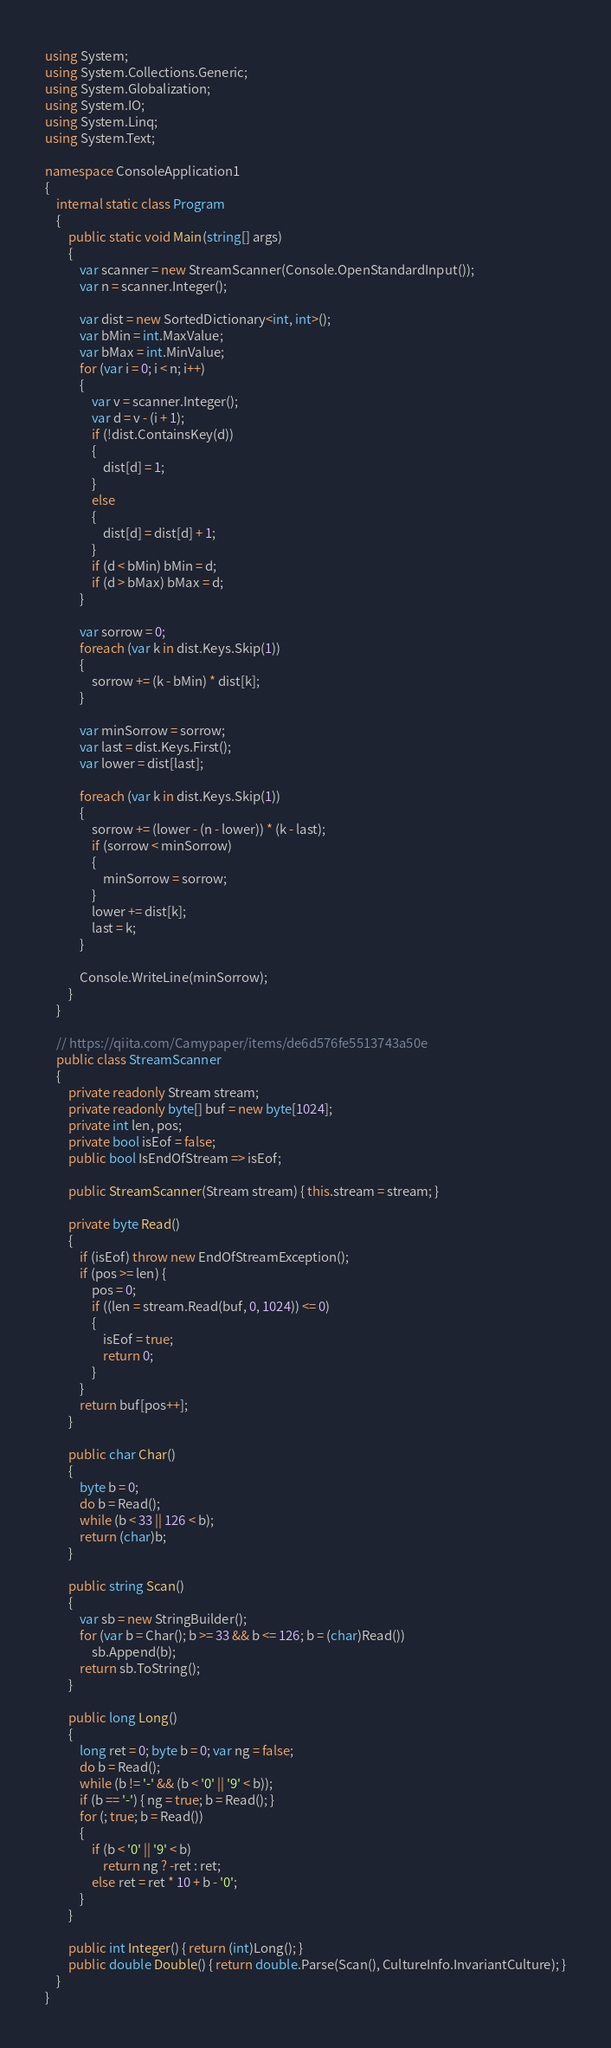<code> <loc_0><loc_0><loc_500><loc_500><_C#_>using System;
using System.Collections.Generic;
using System.Globalization;
using System.IO;
using System.Linq;
using System.Text;

namespace ConsoleApplication1
{
    internal static class Program
    {
        public static void Main(string[] args)
        {
            var scanner = new StreamScanner(Console.OpenStandardInput());
            var n = scanner.Integer();

            var dist = new SortedDictionary<int, int>();
            var bMin = int.MaxValue;
            var bMax = int.MinValue;
            for (var i = 0; i < n; i++)
            {
                var v = scanner.Integer();
                var d = v - (i + 1);
                if (!dist.ContainsKey(d))
                {
                    dist[d] = 1;
                }
                else
                {
                    dist[d] = dist[d] + 1;
                }
                if (d < bMin) bMin = d;
                if (d > bMax) bMax = d;
            }

            var sorrow = 0;
            foreach (var k in dist.Keys.Skip(1))
            {
                sorrow += (k - bMin) * dist[k];
            }
            
            var minSorrow = sorrow;
            var last = dist.Keys.First();
            var lower = dist[last];

            foreach (var k in dist.Keys.Skip(1))
            {
                sorrow += (lower - (n - lower)) * (k - last);
                if (sorrow < minSorrow)
                {
                    minSorrow = sorrow;
                }
                lower += dist[k];
                last = k;
            }
            
            Console.WriteLine(minSorrow);
        }
    }
    
    // https://qiita.com/Camypaper/items/de6d576fe5513743a50e
    public class StreamScanner
    {   
        private readonly Stream stream;
        private readonly byte[] buf = new byte[1024];
        private int len, pos;
        private bool isEof = false;
        public bool IsEndOfStream => isEof;

        public StreamScanner(Stream stream) { this.stream = stream; }
        
        private byte Read()
        {
            if (isEof) throw new EndOfStreamException();
            if (pos >= len) {
                pos = 0;
                if ((len = stream.Read(buf, 0, 1024)) <= 0)
                {
                    isEof = true;
                    return 0;
                }
            }
            return buf[pos++];
        }
        
        public char Char() 
        {
            byte b = 0;
            do b = Read();
            while (b < 33 || 126 < b);
            return (char)b; 
        }
        
        public string Scan()
        {
            var sb = new StringBuilder();
            for (var b = Char(); b >= 33 && b <= 126; b = (char)Read())
                sb.Append(b);
            return sb.ToString();
        }
        
        public long Long()
        {
            long ret = 0; byte b = 0; var ng = false;
            do b = Read();
            while (b != '-' && (b < '0' || '9' < b));
            if (b == '-') { ng = true; b = Read(); }
            for (; true; b = Read())
            {
                if (b < '0' || '9' < b)
                    return ng ? -ret : ret;
                else ret = ret * 10 + b - '0';
            }
        }
        
        public int Integer() { return (int)Long(); }
        public double Double() { return double.Parse(Scan(), CultureInfo.InvariantCulture); }
    }
}
</code> 